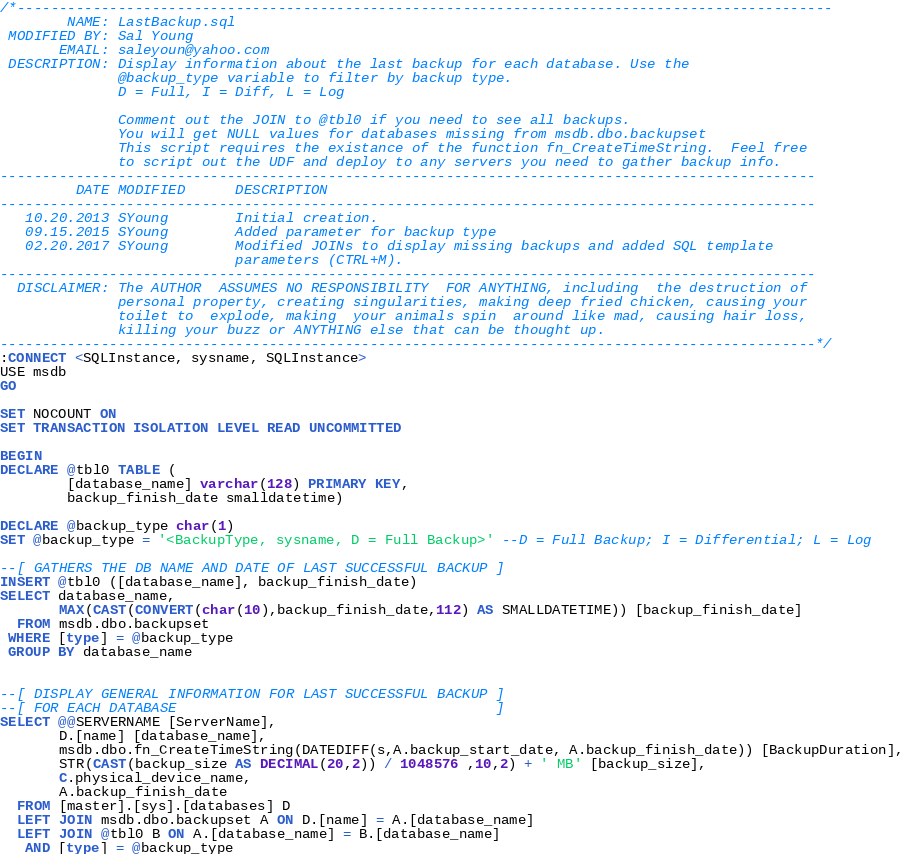<code> <loc_0><loc_0><loc_500><loc_500><_SQL_>/*-------------------------------------------------------------------------------------------------
        NAME: LastBackup.sql
 MODIFIED BY: Sal Young
       EMAIL: saleyoun@yahoo.com
 DESCRIPTION: Display information about the last backup for each database. Use the 
              @backup_type variable to filter by backup type. 
              D = Full, I = Diff, L = Log

              Comment out the JOIN to @tbl0 if you need to see all backups.
              You will get NULL values for databases missing from msdb.dbo.backupset
              This script requires the existance of the function fn_CreateTimeString.  Feel free 
              to script out the UDF and deploy to any servers you need to gather backup info.
-------------------------------------------------------------------------------------------------
         DATE MODIFIED      DESCRIPTION    
-------------------------------------------------------------------------------------------------
   10.20.2013 SYoung        Initial creation.
   09.15.2015 SYoung        Added parameter for backup type
   02.20.2017 SYoung        Modified JOINs to display missing backups and added SQL template
                            parameters (CTRL+M).
-------------------------------------------------------------------------------------------------
  DISCLAIMER: The AUTHOR  ASSUMES NO RESPONSIBILITY  FOR ANYTHING, including  the destruction of 
              personal property, creating singularities, making deep fried chicken, causing your 
              toilet to  explode, making  your animals spin  around like mad, causing hair loss, 
              killing your buzz or ANYTHING else that can be thought up.
-------------------------------------------------------------------------------------------------*/
:CONNECT <SQLInstance, sysname, SQLInstance>
USE msdb
GO
 
SET NOCOUNT ON
SET TRANSACTION ISOLATION LEVEL READ UNCOMMITTED

BEGIN
DECLARE @tbl0 TABLE (
        [database_name] varchar(128) PRIMARY KEY,
        backup_finish_date smalldatetime)
 
DECLARE @backup_type char(1)
SET @backup_type = '<BackupType, sysname, D = Full Backup>' --D = Full Backup; I = Differential; L = Log
 
--[ GATHERS THE DB NAME AND DATE OF LAST SUCCESSFUL BACKUP ]
INSERT @tbl0 ([database_name], backup_finish_date)
SELECT database_name,
       MAX(CAST(CONVERT(char(10),backup_finish_date,112) AS SMALLDATETIME)) [backup_finish_date]
  FROM msdb.dbo.backupset
 WHERE [type] = @backup_type
 GROUP BY database_name
 
 
--[ DISPLAY GENERAL INFORMATION FOR LAST SUCCESSFUL BACKUP ]
--[ FOR EACH DATABASE                                      ]
SELECT @@SERVERNAME [ServerName],
       D.[name] [database_name],
       msdb.dbo.fn_CreateTimeString(DATEDIFF(s,A.backup_start_date, A.backup_finish_date)) [BackupDuration],
       STR(CAST(backup_size AS DECIMAL(20,2)) / 1048576 ,10,2) + ' MB' [backup_size],
       C.physical_device_name,
       A.backup_finish_date
  FROM [master].[sys].[databases] D
  LEFT JOIN msdb.dbo.backupset A ON D.[name] = A.[database_name]
  LEFT JOIN @tbl0 B ON A.[database_name] = B.[database_name]
   AND [type] = @backup_type</code> 